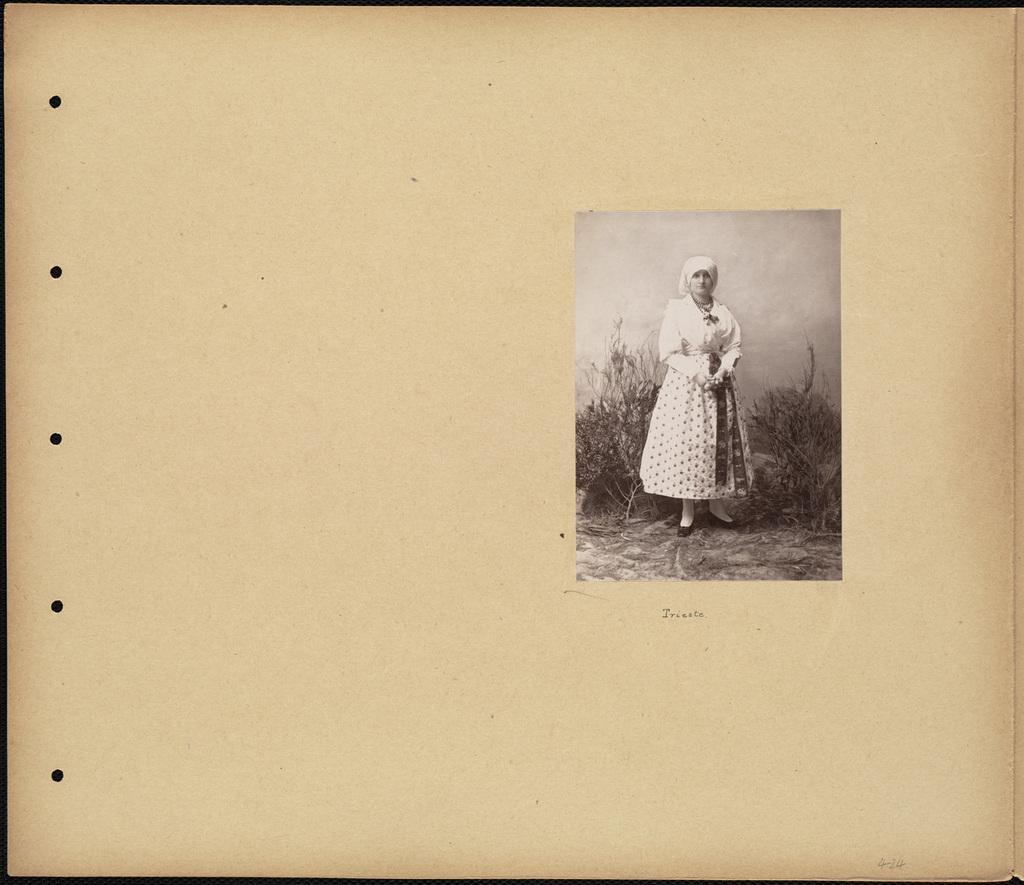Please provide a concise description of this image. In this image, we can see a poster with some images and text. 